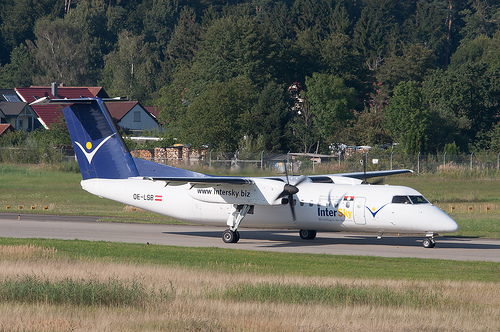Please provide the bounding box coordinate of the region this sentence describes: Name of airplane painted on side. The bounding box coordinates for the region describing 'Name of airplane painted on side' are [0.61, 0.57, 0.72, 0.62]. This area highlights the branding or identification text on the fuselage of the aircraft. 